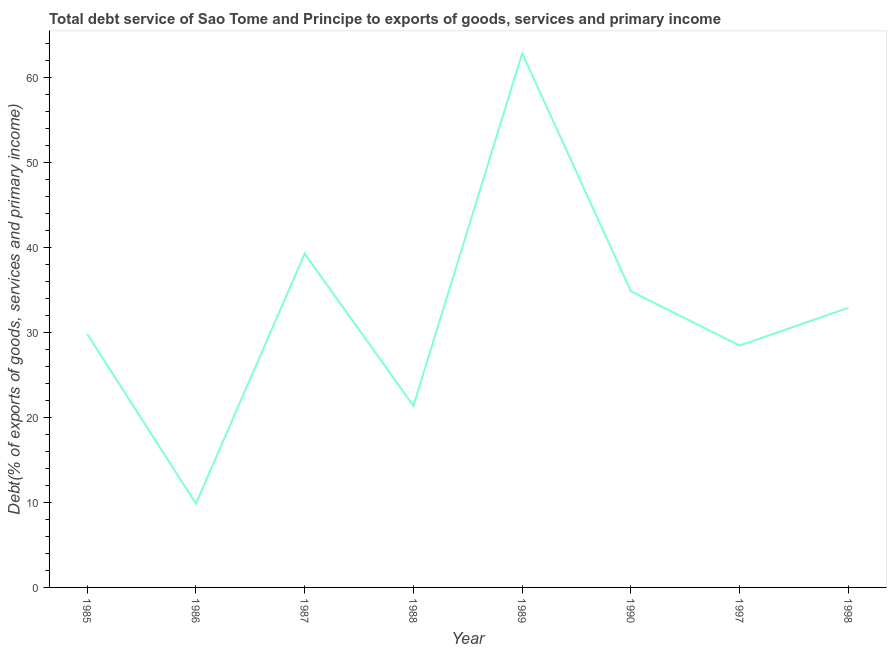What is the total debt service in 1986?
Make the answer very short. 9.85. Across all years, what is the maximum total debt service?
Offer a very short reply. 62.79. Across all years, what is the minimum total debt service?
Ensure brevity in your answer.  9.85. What is the sum of the total debt service?
Make the answer very short. 259.18. What is the difference between the total debt service in 1985 and 1986?
Make the answer very short. 19.95. What is the average total debt service per year?
Offer a very short reply. 32.4. What is the median total debt service?
Provide a succinct answer. 31.34. Do a majority of the years between 1986 and 1997 (inclusive) have total debt service greater than 30 %?
Give a very brief answer. No. What is the ratio of the total debt service in 1990 to that in 1997?
Keep it short and to the point. 1.22. Is the total debt service in 1987 less than that in 1989?
Your answer should be very brief. Yes. What is the difference between the highest and the second highest total debt service?
Ensure brevity in your answer.  23.55. Is the sum of the total debt service in 1986 and 1998 greater than the maximum total debt service across all years?
Provide a short and direct response. No. What is the difference between the highest and the lowest total debt service?
Offer a terse response. 52.94. In how many years, is the total debt service greater than the average total debt service taken over all years?
Keep it short and to the point. 4. How many lines are there?
Your answer should be compact. 1. How many years are there in the graph?
Ensure brevity in your answer.  8. Does the graph contain any zero values?
Your response must be concise. No. Does the graph contain grids?
Make the answer very short. No. What is the title of the graph?
Keep it short and to the point. Total debt service of Sao Tome and Principe to exports of goods, services and primary income. What is the label or title of the Y-axis?
Offer a very short reply. Debt(% of exports of goods, services and primary income). What is the Debt(% of exports of goods, services and primary income) in 1985?
Your answer should be compact. 29.8. What is the Debt(% of exports of goods, services and primary income) of 1986?
Your answer should be compact. 9.85. What is the Debt(% of exports of goods, services and primary income) of 1987?
Give a very brief answer. 39.25. What is the Debt(% of exports of goods, services and primary income) in 1988?
Your answer should be compact. 21.36. What is the Debt(% of exports of goods, services and primary income) in 1989?
Your answer should be compact. 62.79. What is the Debt(% of exports of goods, services and primary income) in 1990?
Keep it short and to the point. 34.82. What is the Debt(% of exports of goods, services and primary income) of 1997?
Offer a very short reply. 28.43. What is the Debt(% of exports of goods, services and primary income) in 1998?
Ensure brevity in your answer.  32.88. What is the difference between the Debt(% of exports of goods, services and primary income) in 1985 and 1986?
Give a very brief answer. 19.95. What is the difference between the Debt(% of exports of goods, services and primary income) in 1985 and 1987?
Give a very brief answer. -9.45. What is the difference between the Debt(% of exports of goods, services and primary income) in 1985 and 1988?
Ensure brevity in your answer.  8.44. What is the difference between the Debt(% of exports of goods, services and primary income) in 1985 and 1989?
Offer a very short reply. -32.99. What is the difference between the Debt(% of exports of goods, services and primary income) in 1985 and 1990?
Your answer should be compact. -5.02. What is the difference between the Debt(% of exports of goods, services and primary income) in 1985 and 1997?
Your answer should be compact. 1.37. What is the difference between the Debt(% of exports of goods, services and primary income) in 1985 and 1998?
Ensure brevity in your answer.  -3.08. What is the difference between the Debt(% of exports of goods, services and primary income) in 1986 and 1987?
Make the answer very short. -29.4. What is the difference between the Debt(% of exports of goods, services and primary income) in 1986 and 1988?
Make the answer very short. -11.51. What is the difference between the Debt(% of exports of goods, services and primary income) in 1986 and 1989?
Offer a terse response. -52.94. What is the difference between the Debt(% of exports of goods, services and primary income) in 1986 and 1990?
Provide a succinct answer. -24.97. What is the difference between the Debt(% of exports of goods, services and primary income) in 1986 and 1997?
Give a very brief answer. -18.59. What is the difference between the Debt(% of exports of goods, services and primary income) in 1986 and 1998?
Offer a very short reply. -23.03. What is the difference between the Debt(% of exports of goods, services and primary income) in 1987 and 1988?
Provide a short and direct response. 17.89. What is the difference between the Debt(% of exports of goods, services and primary income) in 1987 and 1989?
Make the answer very short. -23.55. What is the difference between the Debt(% of exports of goods, services and primary income) in 1987 and 1990?
Provide a short and direct response. 4.43. What is the difference between the Debt(% of exports of goods, services and primary income) in 1987 and 1997?
Provide a short and direct response. 10.81. What is the difference between the Debt(% of exports of goods, services and primary income) in 1987 and 1998?
Give a very brief answer. 6.36. What is the difference between the Debt(% of exports of goods, services and primary income) in 1988 and 1989?
Ensure brevity in your answer.  -41.43. What is the difference between the Debt(% of exports of goods, services and primary income) in 1988 and 1990?
Your answer should be very brief. -13.46. What is the difference between the Debt(% of exports of goods, services and primary income) in 1988 and 1997?
Give a very brief answer. -7.08. What is the difference between the Debt(% of exports of goods, services and primary income) in 1988 and 1998?
Provide a short and direct response. -11.52. What is the difference between the Debt(% of exports of goods, services and primary income) in 1989 and 1990?
Your response must be concise. 27.98. What is the difference between the Debt(% of exports of goods, services and primary income) in 1989 and 1997?
Your answer should be very brief. 34.36. What is the difference between the Debt(% of exports of goods, services and primary income) in 1989 and 1998?
Your response must be concise. 29.91. What is the difference between the Debt(% of exports of goods, services and primary income) in 1990 and 1997?
Make the answer very short. 6.38. What is the difference between the Debt(% of exports of goods, services and primary income) in 1990 and 1998?
Provide a succinct answer. 1.93. What is the difference between the Debt(% of exports of goods, services and primary income) in 1997 and 1998?
Provide a succinct answer. -4.45. What is the ratio of the Debt(% of exports of goods, services and primary income) in 1985 to that in 1986?
Offer a very short reply. 3.03. What is the ratio of the Debt(% of exports of goods, services and primary income) in 1985 to that in 1987?
Offer a very short reply. 0.76. What is the ratio of the Debt(% of exports of goods, services and primary income) in 1985 to that in 1988?
Provide a succinct answer. 1.4. What is the ratio of the Debt(% of exports of goods, services and primary income) in 1985 to that in 1989?
Your response must be concise. 0.47. What is the ratio of the Debt(% of exports of goods, services and primary income) in 1985 to that in 1990?
Ensure brevity in your answer.  0.86. What is the ratio of the Debt(% of exports of goods, services and primary income) in 1985 to that in 1997?
Your response must be concise. 1.05. What is the ratio of the Debt(% of exports of goods, services and primary income) in 1985 to that in 1998?
Keep it short and to the point. 0.91. What is the ratio of the Debt(% of exports of goods, services and primary income) in 1986 to that in 1987?
Your response must be concise. 0.25. What is the ratio of the Debt(% of exports of goods, services and primary income) in 1986 to that in 1988?
Your response must be concise. 0.46. What is the ratio of the Debt(% of exports of goods, services and primary income) in 1986 to that in 1989?
Ensure brevity in your answer.  0.16. What is the ratio of the Debt(% of exports of goods, services and primary income) in 1986 to that in 1990?
Offer a very short reply. 0.28. What is the ratio of the Debt(% of exports of goods, services and primary income) in 1986 to that in 1997?
Keep it short and to the point. 0.35. What is the ratio of the Debt(% of exports of goods, services and primary income) in 1986 to that in 1998?
Keep it short and to the point. 0.3. What is the ratio of the Debt(% of exports of goods, services and primary income) in 1987 to that in 1988?
Your answer should be very brief. 1.84. What is the ratio of the Debt(% of exports of goods, services and primary income) in 1987 to that in 1990?
Make the answer very short. 1.13. What is the ratio of the Debt(% of exports of goods, services and primary income) in 1987 to that in 1997?
Offer a terse response. 1.38. What is the ratio of the Debt(% of exports of goods, services and primary income) in 1987 to that in 1998?
Your answer should be very brief. 1.19. What is the ratio of the Debt(% of exports of goods, services and primary income) in 1988 to that in 1989?
Give a very brief answer. 0.34. What is the ratio of the Debt(% of exports of goods, services and primary income) in 1988 to that in 1990?
Ensure brevity in your answer.  0.61. What is the ratio of the Debt(% of exports of goods, services and primary income) in 1988 to that in 1997?
Your answer should be compact. 0.75. What is the ratio of the Debt(% of exports of goods, services and primary income) in 1988 to that in 1998?
Your answer should be compact. 0.65. What is the ratio of the Debt(% of exports of goods, services and primary income) in 1989 to that in 1990?
Keep it short and to the point. 1.8. What is the ratio of the Debt(% of exports of goods, services and primary income) in 1989 to that in 1997?
Provide a succinct answer. 2.21. What is the ratio of the Debt(% of exports of goods, services and primary income) in 1989 to that in 1998?
Your answer should be very brief. 1.91. What is the ratio of the Debt(% of exports of goods, services and primary income) in 1990 to that in 1997?
Provide a succinct answer. 1.22. What is the ratio of the Debt(% of exports of goods, services and primary income) in 1990 to that in 1998?
Provide a succinct answer. 1.06. What is the ratio of the Debt(% of exports of goods, services and primary income) in 1997 to that in 1998?
Keep it short and to the point. 0.86. 